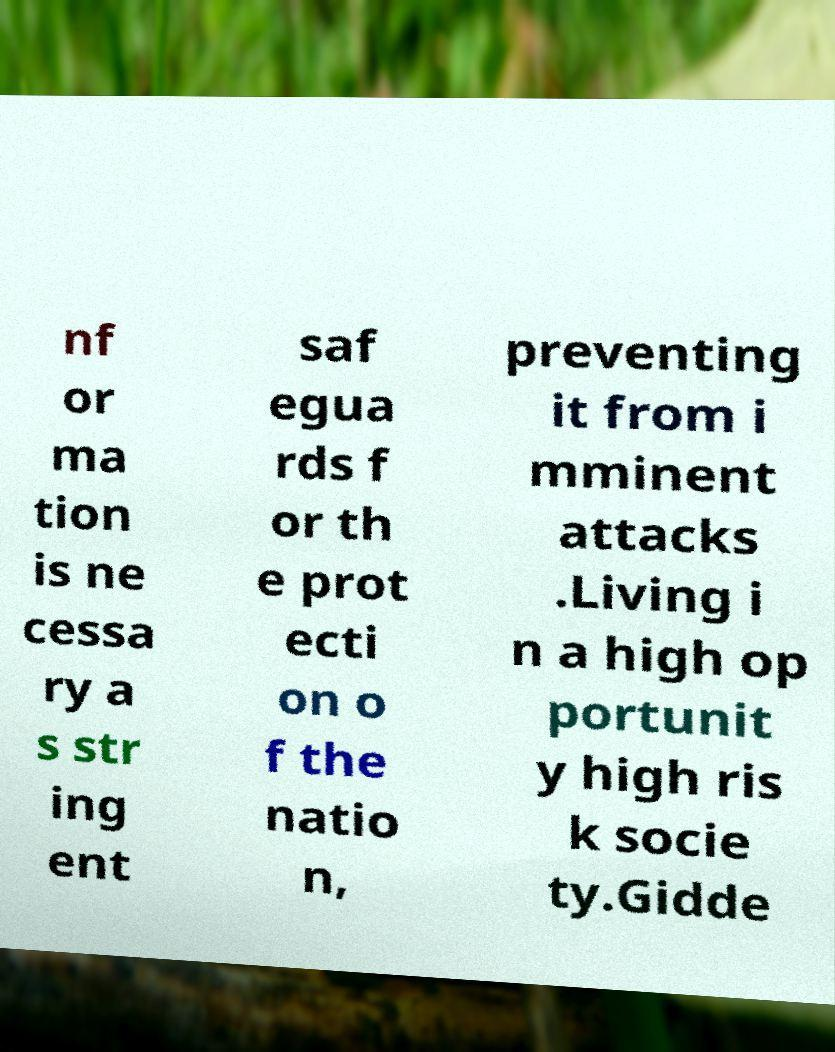Please read and relay the text visible in this image. What does it say? nf or ma tion is ne cessa ry a s str ing ent saf egua rds f or th e prot ecti on o f the natio n, preventing it from i mminent attacks .Living i n a high op portunit y high ris k socie ty.Gidde 